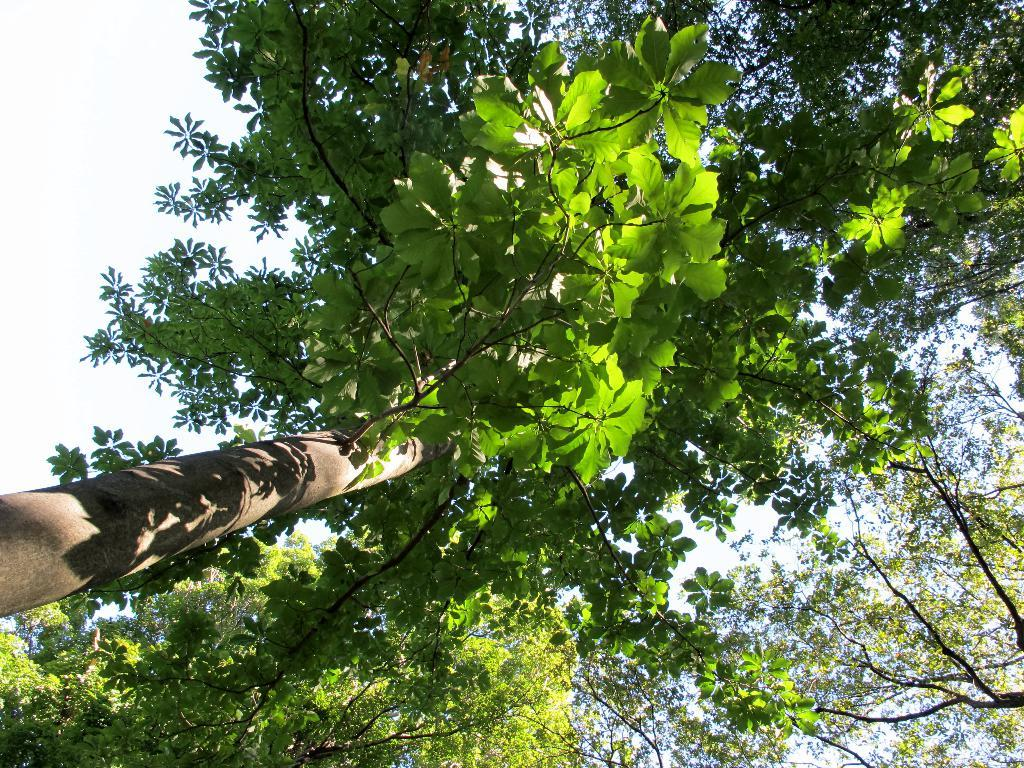What type of vegetation is in the foreground of the image? There are green leaves in the foreground of the image. What color are the branches supporting the leaves? The branches have a brown color. What can be seen at the top of the image? The sky is visible at the top of the image. What type of card can be seen in the image? There is no card present in the image; it features green leaves with brown branches. How many oranges are visible in the image? There are no oranges present in the image. 